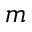<formula> <loc_0><loc_0><loc_500><loc_500>m</formula> 